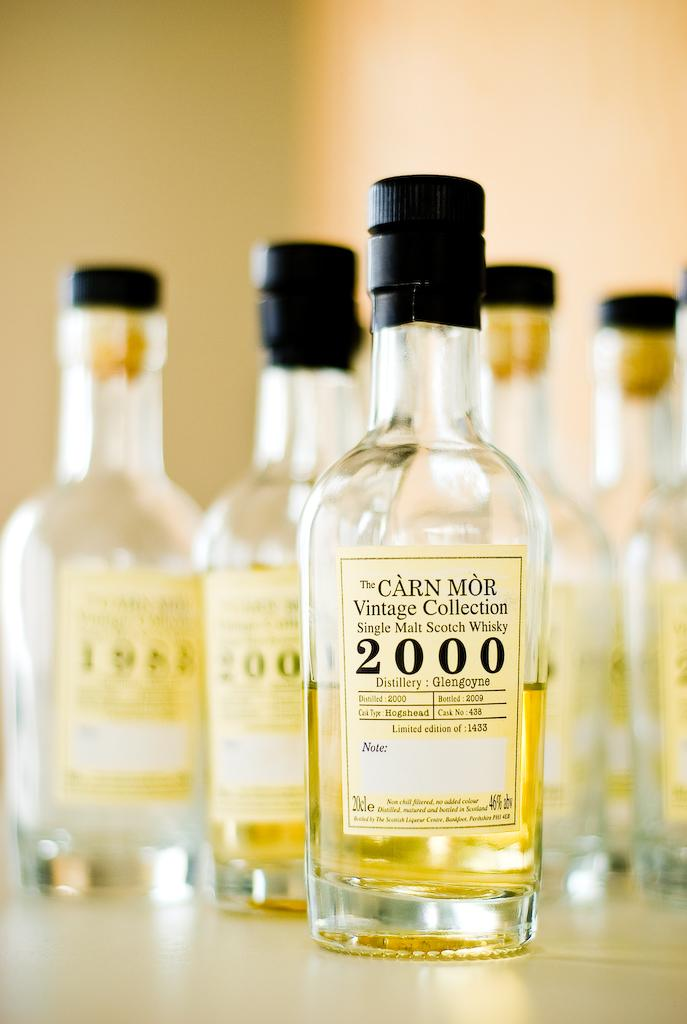How many alcohol bottles are visible in the image? There are five alcohol bottles in the image. Where are the bottles located? The bottles are placed on a table. What can be found on the bottles? There are labels on the bottles. Can you describe the background of the image? The background of the image is blurred. What type of cart can be seen in the background of the image? There is no cart visible in the background of the image. 